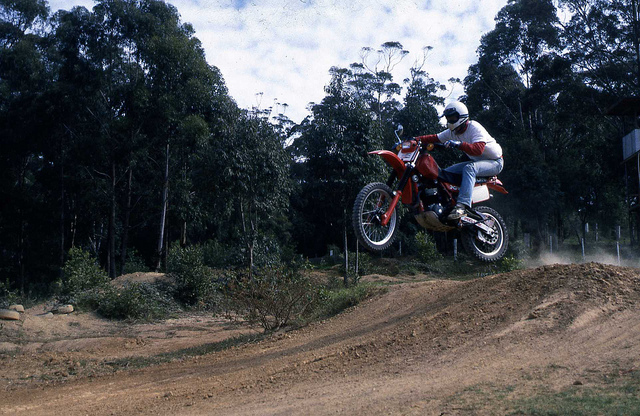<image>What is the speed limit? It is unknown what the speed limit is. It could be '0', '50', '80 mph', or there may be no speed limit. What is the speed limit? The speed limit is unknown. It can be seen '0', '50', 'no speed limit' or 'unknown'. 